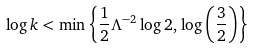Convert formula to latex. <formula><loc_0><loc_0><loc_500><loc_500>\log { k } < \min \left \{ \frac { 1 } { 2 } \Lambda ^ { - 2 } \log 2 , \, \log \left ( \frac { 3 } { 2 } \right ) \right \}</formula> 